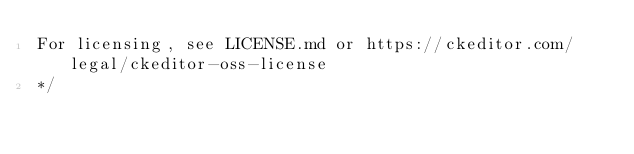<code> <loc_0><loc_0><loc_500><loc_500><_CSS_>For licensing, see LICENSE.md or https://ckeditor.com/legal/ckeditor-oss-license
*/</code> 